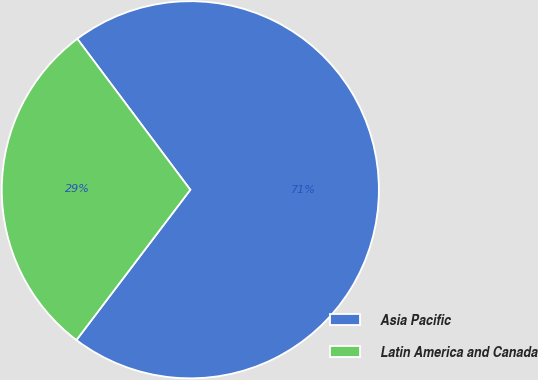<chart> <loc_0><loc_0><loc_500><loc_500><pie_chart><fcel>Asia Pacific<fcel>Latin America and Canada<nl><fcel>70.55%<fcel>29.45%<nl></chart> 